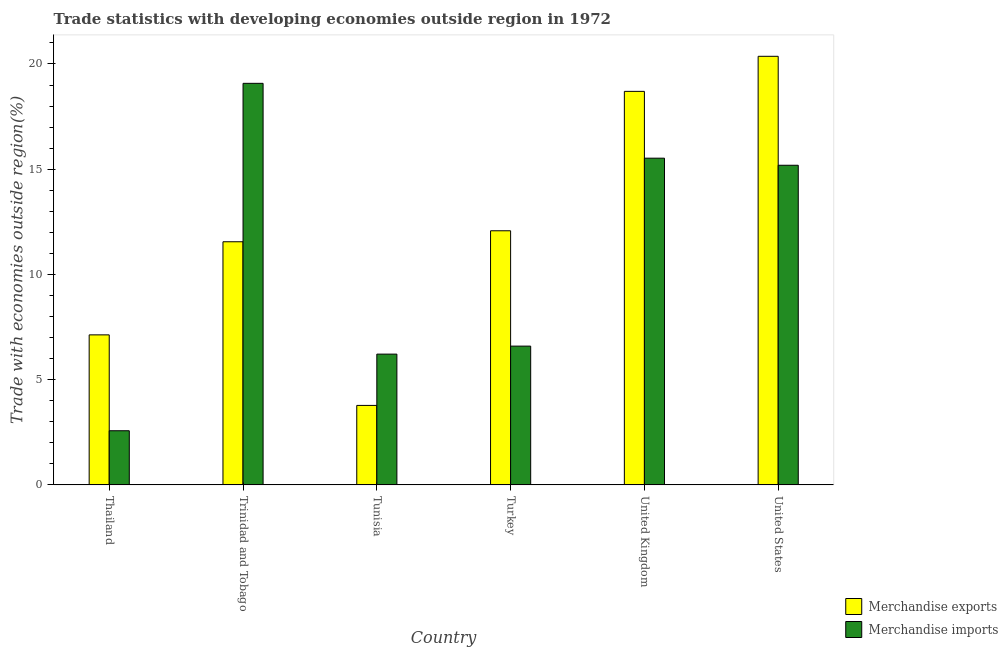How many different coloured bars are there?
Offer a terse response. 2. How many bars are there on the 4th tick from the left?
Give a very brief answer. 2. What is the label of the 1st group of bars from the left?
Provide a succinct answer. Thailand. What is the merchandise exports in Trinidad and Tobago?
Provide a short and direct response. 11.55. Across all countries, what is the maximum merchandise exports?
Keep it short and to the point. 20.36. Across all countries, what is the minimum merchandise exports?
Offer a terse response. 3.78. In which country was the merchandise imports minimum?
Offer a terse response. Thailand. What is the total merchandise exports in the graph?
Your answer should be very brief. 73.59. What is the difference between the merchandise imports in Trinidad and Tobago and that in United States?
Offer a very short reply. 3.89. What is the difference between the merchandise imports in United Kingdom and the merchandise exports in Thailand?
Give a very brief answer. 8.4. What is the average merchandise exports per country?
Give a very brief answer. 12.27. What is the difference between the merchandise exports and merchandise imports in Tunisia?
Provide a short and direct response. -2.44. In how many countries, is the merchandise exports greater than 16 %?
Offer a terse response. 2. What is the ratio of the merchandise exports in Trinidad and Tobago to that in United States?
Your answer should be compact. 0.57. What is the difference between the highest and the second highest merchandise exports?
Your answer should be compact. 1.67. What is the difference between the highest and the lowest merchandise exports?
Give a very brief answer. 16.59. What does the 1st bar from the left in Tunisia represents?
Keep it short and to the point. Merchandise exports. What does the 2nd bar from the right in Thailand represents?
Give a very brief answer. Merchandise exports. Are all the bars in the graph horizontal?
Your answer should be compact. No. What is the difference between two consecutive major ticks on the Y-axis?
Your answer should be very brief. 5. Are the values on the major ticks of Y-axis written in scientific E-notation?
Your answer should be compact. No. Does the graph contain any zero values?
Give a very brief answer. No. Where does the legend appear in the graph?
Provide a short and direct response. Bottom right. How many legend labels are there?
Provide a short and direct response. 2. What is the title of the graph?
Provide a short and direct response. Trade statistics with developing economies outside region in 1972. What is the label or title of the X-axis?
Ensure brevity in your answer.  Country. What is the label or title of the Y-axis?
Your answer should be compact. Trade with economies outside region(%). What is the Trade with economies outside region(%) in Merchandise exports in Thailand?
Your answer should be compact. 7.13. What is the Trade with economies outside region(%) of Merchandise imports in Thailand?
Offer a very short reply. 2.57. What is the Trade with economies outside region(%) in Merchandise exports in Trinidad and Tobago?
Provide a succinct answer. 11.55. What is the Trade with economies outside region(%) in Merchandise imports in Trinidad and Tobago?
Provide a short and direct response. 19.08. What is the Trade with economies outside region(%) in Merchandise exports in Tunisia?
Ensure brevity in your answer.  3.78. What is the Trade with economies outside region(%) of Merchandise imports in Tunisia?
Give a very brief answer. 6.21. What is the Trade with economies outside region(%) of Merchandise exports in Turkey?
Ensure brevity in your answer.  12.07. What is the Trade with economies outside region(%) in Merchandise imports in Turkey?
Make the answer very short. 6.59. What is the Trade with economies outside region(%) in Merchandise exports in United Kingdom?
Your answer should be compact. 18.7. What is the Trade with economies outside region(%) in Merchandise imports in United Kingdom?
Offer a terse response. 15.52. What is the Trade with economies outside region(%) of Merchandise exports in United States?
Your answer should be very brief. 20.36. What is the Trade with economies outside region(%) of Merchandise imports in United States?
Your answer should be very brief. 15.19. Across all countries, what is the maximum Trade with economies outside region(%) of Merchandise exports?
Your answer should be compact. 20.36. Across all countries, what is the maximum Trade with economies outside region(%) in Merchandise imports?
Provide a succinct answer. 19.08. Across all countries, what is the minimum Trade with economies outside region(%) of Merchandise exports?
Make the answer very short. 3.78. Across all countries, what is the minimum Trade with economies outside region(%) of Merchandise imports?
Make the answer very short. 2.57. What is the total Trade with economies outside region(%) of Merchandise exports in the graph?
Offer a terse response. 73.59. What is the total Trade with economies outside region(%) of Merchandise imports in the graph?
Give a very brief answer. 65.17. What is the difference between the Trade with economies outside region(%) in Merchandise exports in Thailand and that in Trinidad and Tobago?
Ensure brevity in your answer.  -4.42. What is the difference between the Trade with economies outside region(%) in Merchandise imports in Thailand and that in Trinidad and Tobago?
Your response must be concise. -16.51. What is the difference between the Trade with economies outside region(%) in Merchandise exports in Thailand and that in Tunisia?
Your response must be concise. 3.35. What is the difference between the Trade with economies outside region(%) of Merchandise imports in Thailand and that in Tunisia?
Make the answer very short. -3.64. What is the difference between the Trade with economies outside region(%) of Merchandise exports in Thailand and that in Turkey?
Offer a very short reply. -4.95. What is the difference between the Trade with economies outside region(%) in Merchandise imports in Thailand and that in Turkey?
Your response must be concise. -4.02. What is the difference between the Trade with economies outside region(%) of Merchandise exports in Thailand and that in United Kingdom?
Provide a succinct answer. -11.57. What is the difference between the Trade with economies outside region(%) of Merchandise imports in Thailand and that in United Kingdom?
Provide a succinct answer. -12.95. What is the difference between the Trade with economies outside region(%) in Merchandise exports in Thailand and that in United States?
Your response must be concise. -13.24. What is the difference between the Trade with economies outside region(%) of Merchandise imports in Thailand and that in United States?
Keep it short and to the point. -12.61. What is the difference between the Trade with economies outside region(%) in Merchandise exports in Trinidad and Tobago and that in Tunisia?
Your answer should be compact. 7.78. What is the difference between the Trade with economies outside region(%) in Merchandise imports in Trinidad and Tobago and that in Tunisia?
Provide a succinct answer. 12.87. What is the difference between the Trade with economies outside region(%) in Merchandise exports in Trinidad and Tobago and that in Turkey?
Give a very brief answer. -0.52. What is the difference between the Trade with economies outside region(%) in Merchandise imports in Trinidad and Tobago and that in Turkey?
Your answer should be very brief. 12.49. What is the difference between the Trade with economies outside region(%) of Merchandise exports in Trinidad and Tobago and that in United Kingdom?
Your response must be concise. -7.15. What is the difference between the Trade with economies outside region(%) in Merchandise imports in Trinidad and Tobago and that in United Kingdom?
Your answer should be compact. 3.56. What is the difference between the Trade with economies outside region(%) of Merchandise exports in Trinidad and Tobago and that in United States?
Make the answer very short. -8.81. What is the difference between the Trade with economies outside region(%) of Merchandise imports in Trinidad and Tobago and that in United States?
Give a very brief answer. 3.89. What is the difference between the Trade with economies outside region(%) of Merchandise exports in Tunisia and that in Turkey?
Offer a terse response. -8.3. What is the difference between the Trade with economies outside region(%) in Merchandise imports in Tunisia and that in Turkey?
Ensure brevity in your answer.  -0.38. What is the difference between the Trade with economies outside region(%) of Merchandise exports in Tunisia and that in United Kingdom?
Provide a short and direct response. -14.92. What is the difference between the Trade with economies outside region(%) of Merchandise imports in Tunisia and that in United Kingdom?
Your answer should be very brief. -9.31. What is the difference between the Trade with economies outside region(%) in Merchandise exports in Tunisia and that in United States?
Offer a very short reply. -16.59. What is the difference between the Trade with economies outside region(%) in Merchandise imports in Tunisia and that in United States?
Your response must be concise. -8.97. What is the difference between the Trade with economies outside region(%) in Merchandise exports in Turkey and that in United Kingdom?
Provide a short and direct response. -6.62. What is the difference between the Trade with economies outside region(%) in Merchandise imports in Turkey and that in United Kingdom?
Give a very brief answer. -8.93. What is the difference between the Trade with economies outside region(%) in Merchandise exports in Turkey and that in United States?
Your answer should be very brief. -8.29. What is the difference between the Trade with economies outside region(%) in Merchandise imports in Turkey and that in United States?
Provide a short and direct response. -8.59. What is the difference between the Trade with economies outside region(%) of Merchandise exports in United Kingdom and that in United States?
Provide a succinct answer. -1.67. What is the difference between the Trade with economies outside region(%) of Merchandise imports in United Kingdom and that in United States?
Your answer should be very brief. 0.34. What is the difference between the Trade with economies outside region(%) of Merchandise exports in Thailand and the Trade with economies outside region(%) of Merchandise imports in Trinidad and Tobago?
Your answer should be compact. -11.95. What is the difference between the Trade with economies outside region(%) in Merchandise exports in Thailand and the Trade with economies outside region(%) in Merchandise imports in Tunisia?
Offer a very short reply. 0.91. What is the difference between the Trade with economies outside region(%) in Merchandise exports in Thailand and the Trade with economies outside region(%) in Merchandise imports in Turkey?
Ensure brevity in your answer.  0.53. What is the difference between the Trade with economies outside region(%) of Merchandise exports in Thailand and the Trade with economies outside region(%) of Merchandise imports in United Kingdom?
Provide a succinct answer. -8.4. What is the difference between the Trade with economies outside region(%) in Merchandise exports in Thailand and the Trade with economies outside region(%) in Merchandise imports in United States?
Offer a very short reply. -8.06. What is the difference between the Trade with economies outside region(%) of Merchandise exports in Trinidad and Tobago and the Trade with economies outside region(%) of Merchandise imports in Tunisia?
Ensure brevity in your answer.  5.34. What is the difference between the Trade with economies outside region(%) in Merchandise exports in Trinidad and Tobago and the Trade with economies outside region(%) in Merchandise imports in Turkey?
Make the answer very short. 4.96. What is the difference between the Trade with economies outside region(%) of Merchandise exports in Trinidad and Tobago and the Trade with economies outside region(%) of Merchandise imports in United Kingdom?
Give a very brief answer. -3.97. What is the difference between the Trade with economies outside region(%) in Merchandise exports in Trinidad and Tobago and the Trade with economies outside region(%) in Merchandise imports in United States?
Your answer should be compact. -3.64. What is the difference between the Trade with economies outside region(%) in Merchandise exports in Tunisia and the Trade with economies outside region(%) in Merchandise imports in Turkey?
Ensure brevity in your answer.  -2.82. What is the difference between the Trade with economies outside region(%) in Merchandise exports in Tunisia and the Trade with economies outside region(%) in Merchandise imports in United Kingdom?
Offer a very short reply. -11.75. What is the difference between the Trade with economies outside region(%) in Merchandise exports in Tunisia and the Trade with economies outside region(%) in Merchandise imports in United States?
Your answer should be very brief. -11.41. What is the difference between the Trade with economies outside region(%) of Merchandise exports in Turkey and the Trade with economies outside region(%) of Merchandise imports in United Kingdom?
Offer a very short reply. -3.45. What is the difference between the Trade with economies outside region(%) of Merchandise exports in Turkey and the Trade with economies outside region(%) of Merchandise imports in United States?
Ensure brevity in your answer.  -3.11. What is the difference between the Trade with economies outside region(%) in Merchandise exports in United Kingdom and the Trade with economies outside region(%) in Merchandise imports in United States?
Keep it short and to the point. 3.51. What is the average Trade with economies outside region(%) of Merchandise exports per country?
Your answer should be very brief. 12.27. What is the average Trade with economies outside region(%) of Merchandise imports per country?
Provide a succinct answer. 10.86. What is the difference between the Trade with economies outside region(%) of Merchandise exports and Trade with economies outside region(%) of Merchandise imports in Thailand?
Provide a short and direct response. 4.56. What is the difference between the Trade with economies outside region(%) in Merchandise exports and Trade with economies outside region(%) in Merchandise imports in Trinidad and Tobago?
Provide a succinct answer. -7.53. What is the difference between the Trade with economies outside region(%) of Merchandise exports and Trade with economies outside region(%) of Merchandise imports in Tunisia?
Your response must be concise. -2.44. What is the difference between the Trade with economies outside region(%) in Merchandise exports and Trade with economies outside region(%) in Merchandise imports in Turkey?
Provide a succinct answer. 5.48. What is the difference between the Trade with economies outside region(%) of Merchandise exports and Trade with economies outside region(%) of Merchandise imports in United Kingdom?
Your answer should be compact. 3.17. What is the difference between the Trade with economies outside region(%) of Merchandise exports and Trade with economies outside region(%) of Merchandise imports in United States?
Ensure brevity in your answer.  5.18. What is the ratio of the Trade with economies outside region(%) of Merchandise exports in Thailand to that in Trinidad and Tobago?
Ensure brevity in your answer.  0.62. What is the ratio of the Trade with economies outside region(%) of Merchandise imports in Thailand to that in Trinidad and Tobago?
Your answer should be compact. 0.13. What is the ratio of the Trade with economies outside region(%) of Merchandise exports in Thailand to that in Tunisia?
Ensure brevity in your answer.  1.89. What is the ratio of the Trade with economies outside region(%) of Merchandise imports in Thailand to that in Tunisia?
Give a very brief answer. 0.41. What is the ratio of the Trade with economies outside region(%) of Merchandise exports in Thailand to that in Turkey?
Provide a short and direct response. 0.59. What is the ratio of the Trade with economies outside region(%) of Merchandise imports in Thailand to that in Turkey?
Provide a succinct answer. 0.39. What is the ratio of the Trade with economies outside region(%) of Merchandise exports in Thailand to that in United Kingdom?
Offer a terse response. 0.38. What is the ratio of the Trade with economies outside region(%) in Merchandise imports in Thailand to that in United Kingdom?
Provide a short and direct response. 0.17. What is the ratio of the Trade with economies outside region(%) of Merchandise imports in Thailand to that in United States?
Offer a very short reply. 0.17. What is the ratio of the Trade with economies outside region(%) of Merchandise exports in Trinidad and Tobago to that in Tunisia?
Your response must be concise. 3.06. What is the ratio of the Trade with economies outside region(%) of Merchandise imports in Trinidad and Tobago to that in Tunisia?
Your response must be concise. 3.07. What is the ratio of the Trade with economies outside region(%) in Merchandise exports in Trinidad and Tobago to that in Turkey?
Offer a terse response. 0.96. What is the ratio of the Trade with economies outside region(%) of Merchandise imports in Trinidad and Tobago to that in Turkey?
Your answer should be very brief. 2.89. What is the ratio of the Trade with economies outside region(%) in Merchandise exports in Trinidad and Tobago to that in United Kingdom?
Your response must be concise. 0.62. What is the ratio of the Trade with economies outside region(%) in Merchandise imports in Trinidad and Tobago to that in United Kingdom?
Offer a very short reply. 1.23. What is the ratio of the Trade with economies outside region(%) of Merchandise exports in Trinidad and Tobago to that in United States?
Provide a short and direct response. 0.57. What is the ratio of the Trade with economies outside region(%) in Merchandise imports in Trinidad and Tobago to that in United States?
Your answer should be compact. 1.26. What is the ratio of the Trade with economies outside region(%) in Merchandise exports in Tunisia to that in Turkey?
Your answer should be very brief. 0.31. What is the ratio of the Trade with economies outside region(%) of Merchandise imports in Tunisia to that in Turkey?
Your answer should be very brief. 0.94. What is the ratio of the Trade with economies outside region(%) in Merchandise exports in Tunisia to that in United Kingdom?
Make the answer very short. 0.2. What is the ratio of the Trade with economies outside region(%) in Merchandise imports in Tunisia to that in United Kingdom?
Your response must be concise. 0.4. What is the ratio of the Trade with economies outside region(%) of Merchandise exports in Tunisia to that in United States?
Ensure brevity in your answer.  0.19. What is the ratio of the Trade with economies outside region(%) of Merchandise imports in Tunisia to that in United States?
Keep it short and to the point. 0.41. What is the ratio of the Trade with economies outside region(%) in Merchandise exports in Turkey to that in United Kingdom?
Provide a short and direct response. 0.65. What is the ratio of the Trade with economies outside region(%) of Merchandise imports in Turkey to that in United Kingdom?
Your response must be concise. 0.42. What is the ratio of the Trade with economies outside region(%) in Merchandise exports in Turkey to that in United States?
Keep it short and to the point. 0.59. What is the ratio of the Trade with economies outside region(%) of Merchandise imports in Turkey to that in United States?
Give a very brief answer. 0.43. What is the ratio of the Trade with economies outside region(%) in Merchandise exports in United Kingdom to that in United States?
Your answer should be very brief. 0.92. What is the ratio of the Trade with economies outside region(%) in Merchandise imports in United Kingdom to that in United States?
Your answer should be compact. 1.02. What is the difference between the highest and the second highest Trade with economies outside region(%) of Merchandise exports?
Offer a very short reply. 1.67. What is the difference between the highest and the second highest Trade with economies outside region(%) in Merchandise imports?
Give a very brief answer. 3.56. What is the difference between the highest and the lowest Trade with economies outside region(%) of Merchandise exports?
Offer a very short reply. 16.59. What is the difference between the highest and the lowest Trade with economies outside region(%) of Merchandise imports?
Give a very brief answer. 16.51. 